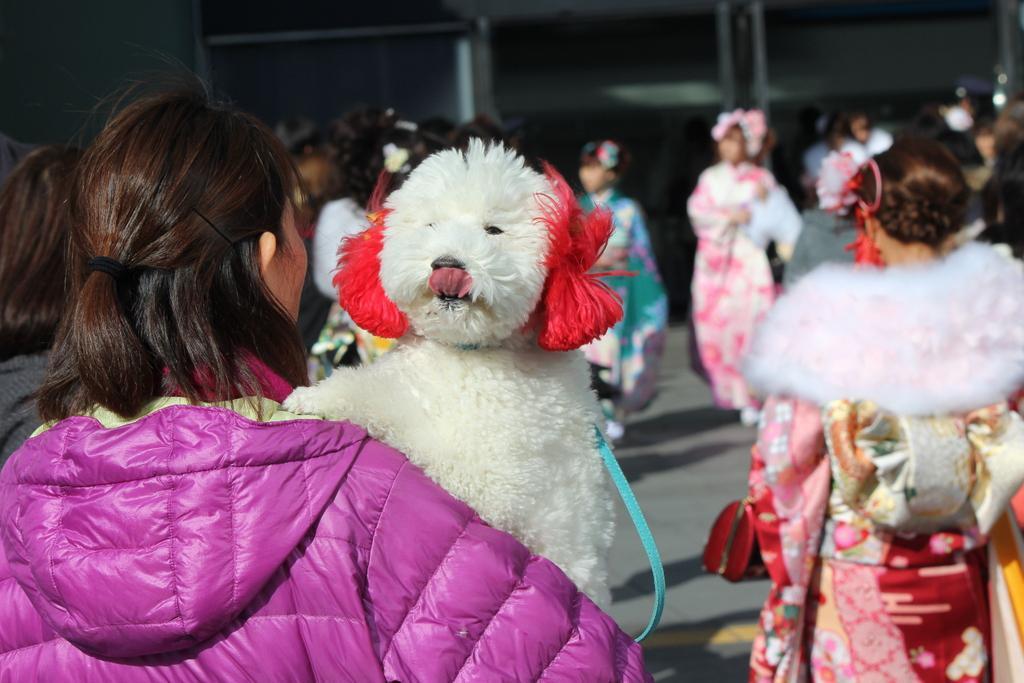Please provide a concise description of this image. In this image I see lot of people who are standing and I see a dog over here. 